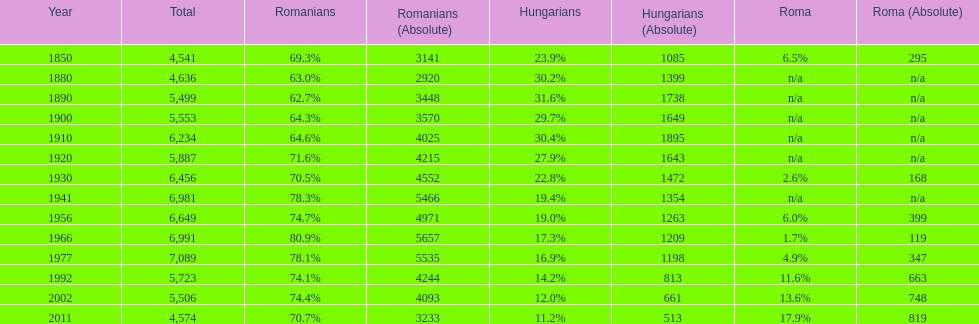Which year had a total of 6,981 and 19.4% hungarians? 1941. 